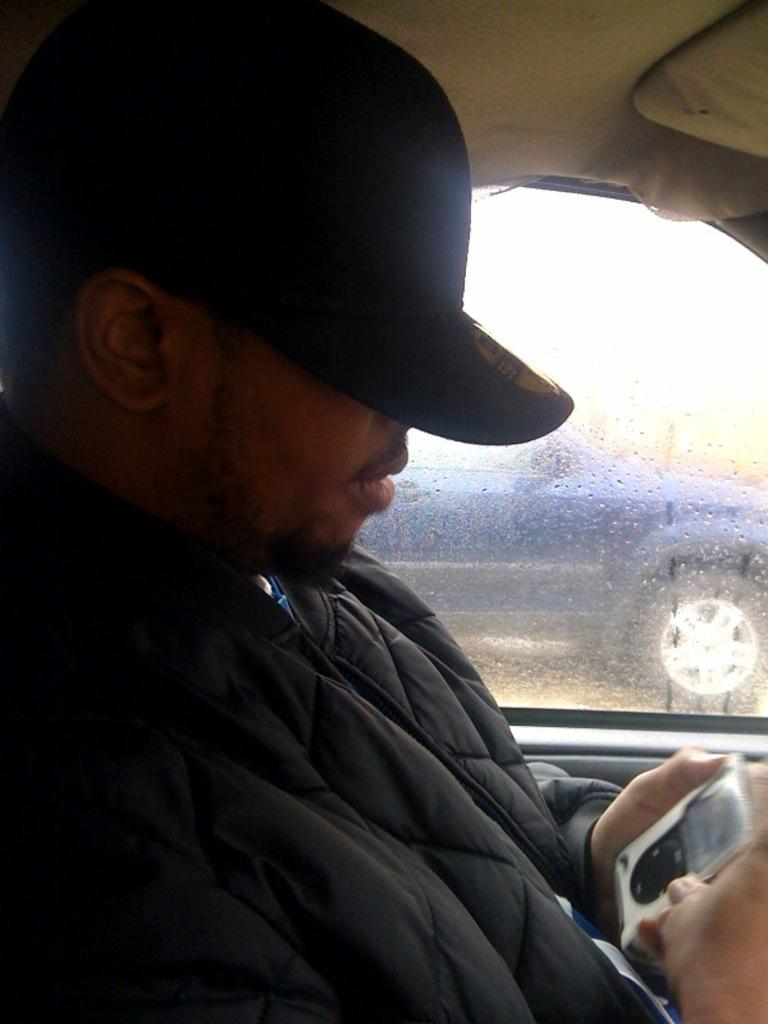What is the person in the image doing? There is a person sitting inside a car in the image. What is the person holding in the image? The person is holding an object in the image. What feature of the car is visible in the image? There is a window in the car. What can be seen through the window in the car? Another car is visible through the window in the image. What type of feeling does the person's tongue have in the image? There is no mention of a tongue in the image, so it is not possible to determine what type of feeling the person's tongue might have. 